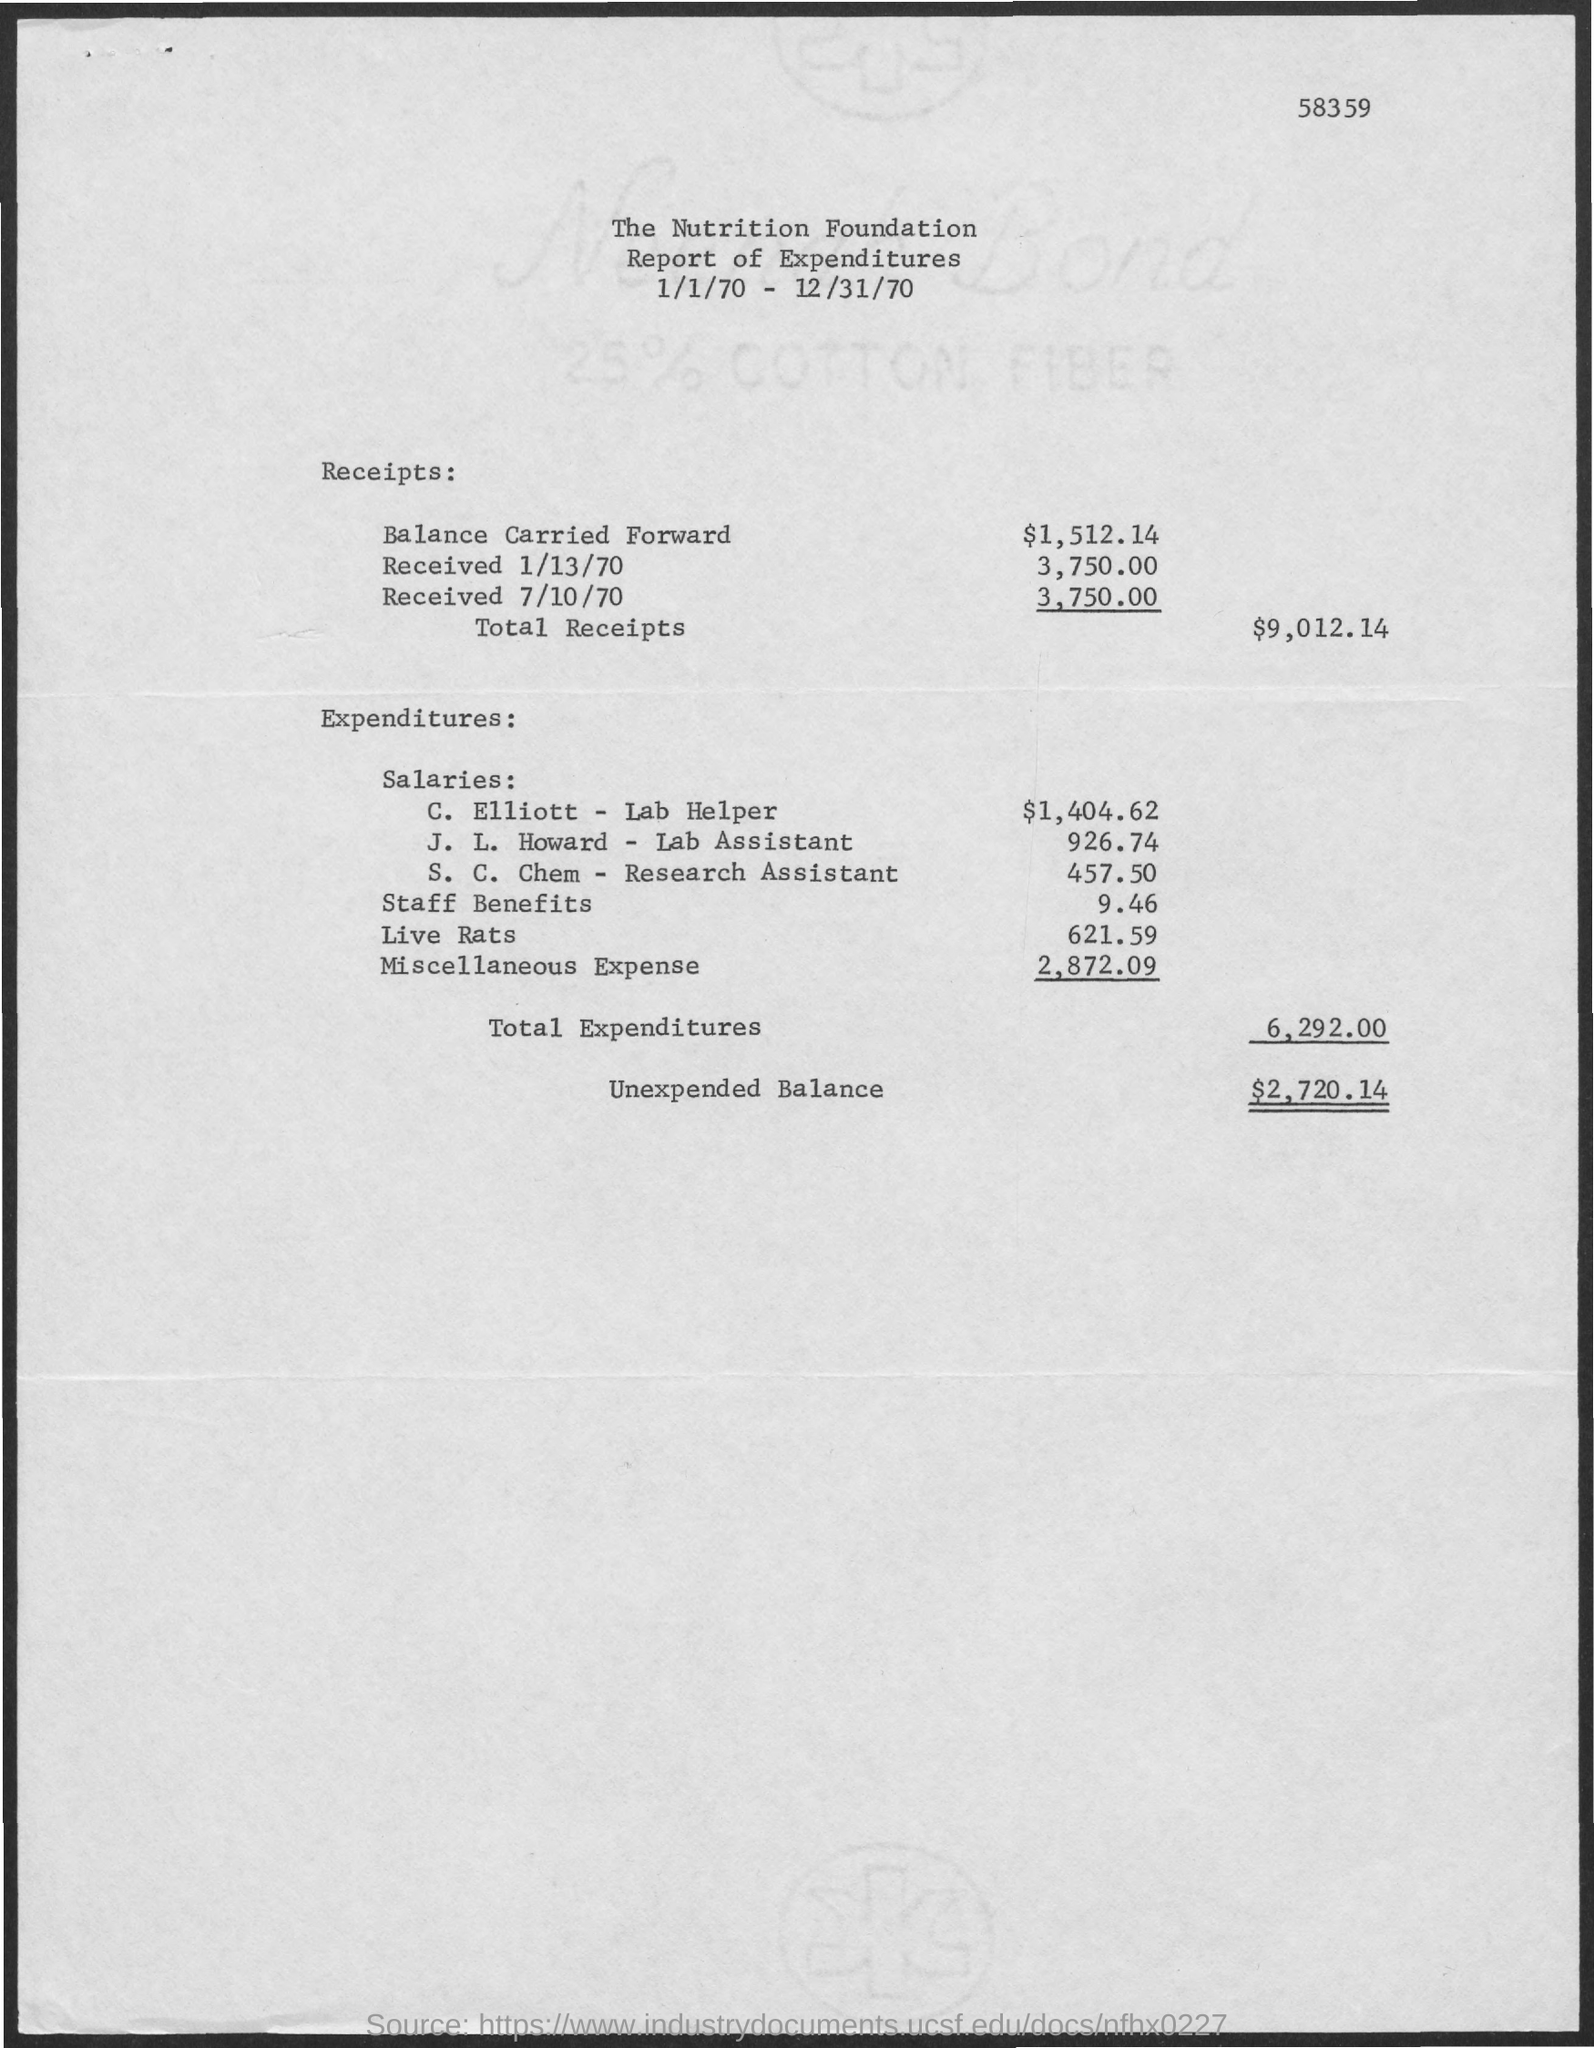What is the amount of balance carried forward mentioned in the given report ?
Offer a terse response. $ 1,512.14. How much amount is received on 1/13/70 ?
Your answer should be compact. 3,750.00. How much amount is received on 7/10/70 ?
Offer a very short reply. 3,750.00. What is the amount of total receipts mentioned in the given report ?
Your answer should be very brief. $ 9,012.14. What is the salary given to c. elliott - lab helper ?
Your response must be concise. $1,404.62. What is the salary given for j.l.howard - lab assistant ?
Provide a succinct answer. $ 926.74. What is the amount of miscellaneous expense mentioned in the given report ?
Offer a terse response. 2,872.09. What is the amount of staff benefits mentioned in the given report ?
Keep it short and to the point. $9.46. What is the amount of total expenditures mentioned in the given report ?
Your answer should be compact. 6,292.00. What is the amount of unexpended balance mentioned in the given report ?
Offer a very short reply. $ 2,720.14. 